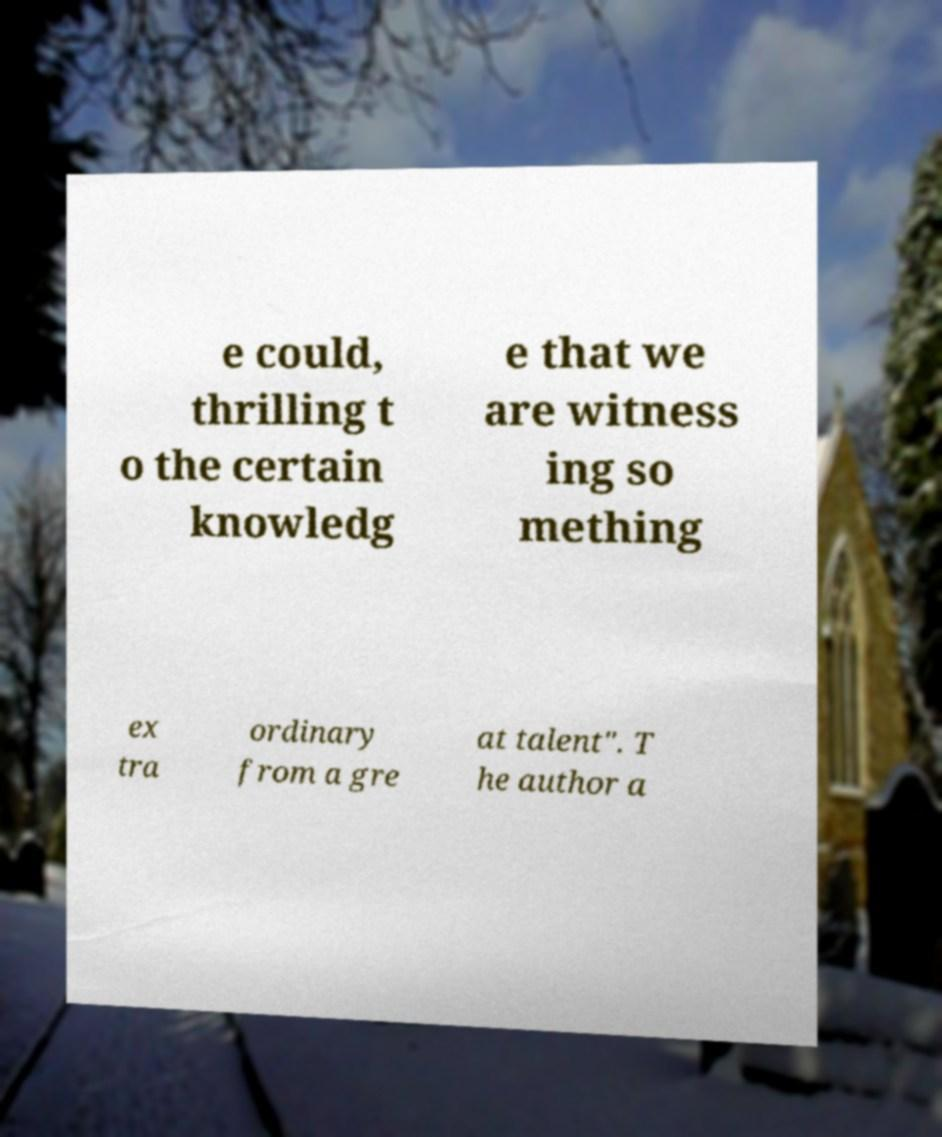Please identify and transcribe the text found in this image. e could, thrilling t o the certain knowledg e that we are witness ing so mething ex tra ordinary from a gre at talent". T he author a 